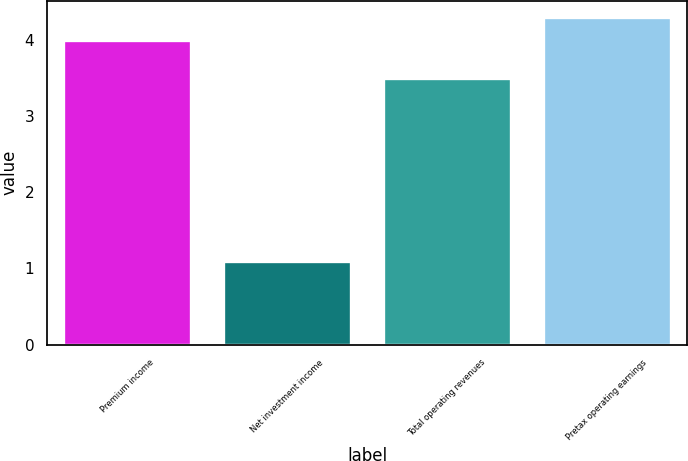<chart> <loc_0><loc_0><loc_500><loc_500><bar_chart><fcel>Premium income<fcel>Net investment income<fcel>Total operating revenues<fcel>Pretax operating earnings<nl><fcel>4<fcel>1.1<fcel>3.5<fcel>4.3<nl></chart> 